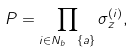Convert formula to latex. <formula><loc_0><loc_0><loc_500><loc_500>P = \prod _ { i \in N _ { b } \ \{ a \} } \sigma _ { z } ^ { ( i ) } ,</formula> 